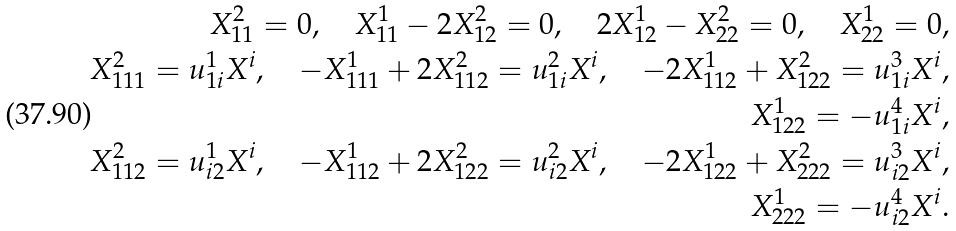<formula> <loc_0><loc_0><loc_500><loc_500>X ^ { 2 } _ { 1 1 } = 0 , \quad X ^ { 1 } _ { 1 1 } - 2 X ^ { 2 } _ { 1 2 } = 0 , \quad 2 X ^ { 1 } _ { 1 2 } - X ^ { 2 } _ { 2 2 } = 0 , \quad X ^ { 1 } _ { 2 2 } = 0 , \\ X ^ { 2 } _ { 1 1 1 } = u ^ { 1 } _ { 1 i } X ^ { i } , \quad - X ^ { 1 } _ { 1 1 1 } + 2 X ^ { 2 } _ { 1 1 2 } = u ^ { 2 } _ { 1 i } X ^ { i } , \quad - 2 X ^ { 1 } _ { 1 1 2 } + X ^ { 2 } _ { 1 2 2 } = u ^ { 3 } _ { 1 i } X ^ { i } , \\ X ^ { 1 } _ { 1 2 2 } = - u ^ { 4 } _ { 1 i } X ^ { i } , \\ X ^ { 2 } _ { 1 1 2 } = u ^ { 1 } _ { i 2 } X ^ { i } , \quad - X ^ { 1 } _ { 1 1 2 } + 2 X ^ { 2 } _ { 1 2 2 } = u ^ { 2 } _ { i 2 } X ^ { i } , \quad - 2 X ^ { 1 } _ { 1 2 2 } + X ^ { 2 } _ { 2 2 2 } = u ^ { 3 } _ { i 2 } X ^ { i } , \\ X ^ { 1 } _ { 2 2 2 } = - u ^ { 4 } _ { i 2 } X ^ { i } .</formula> 